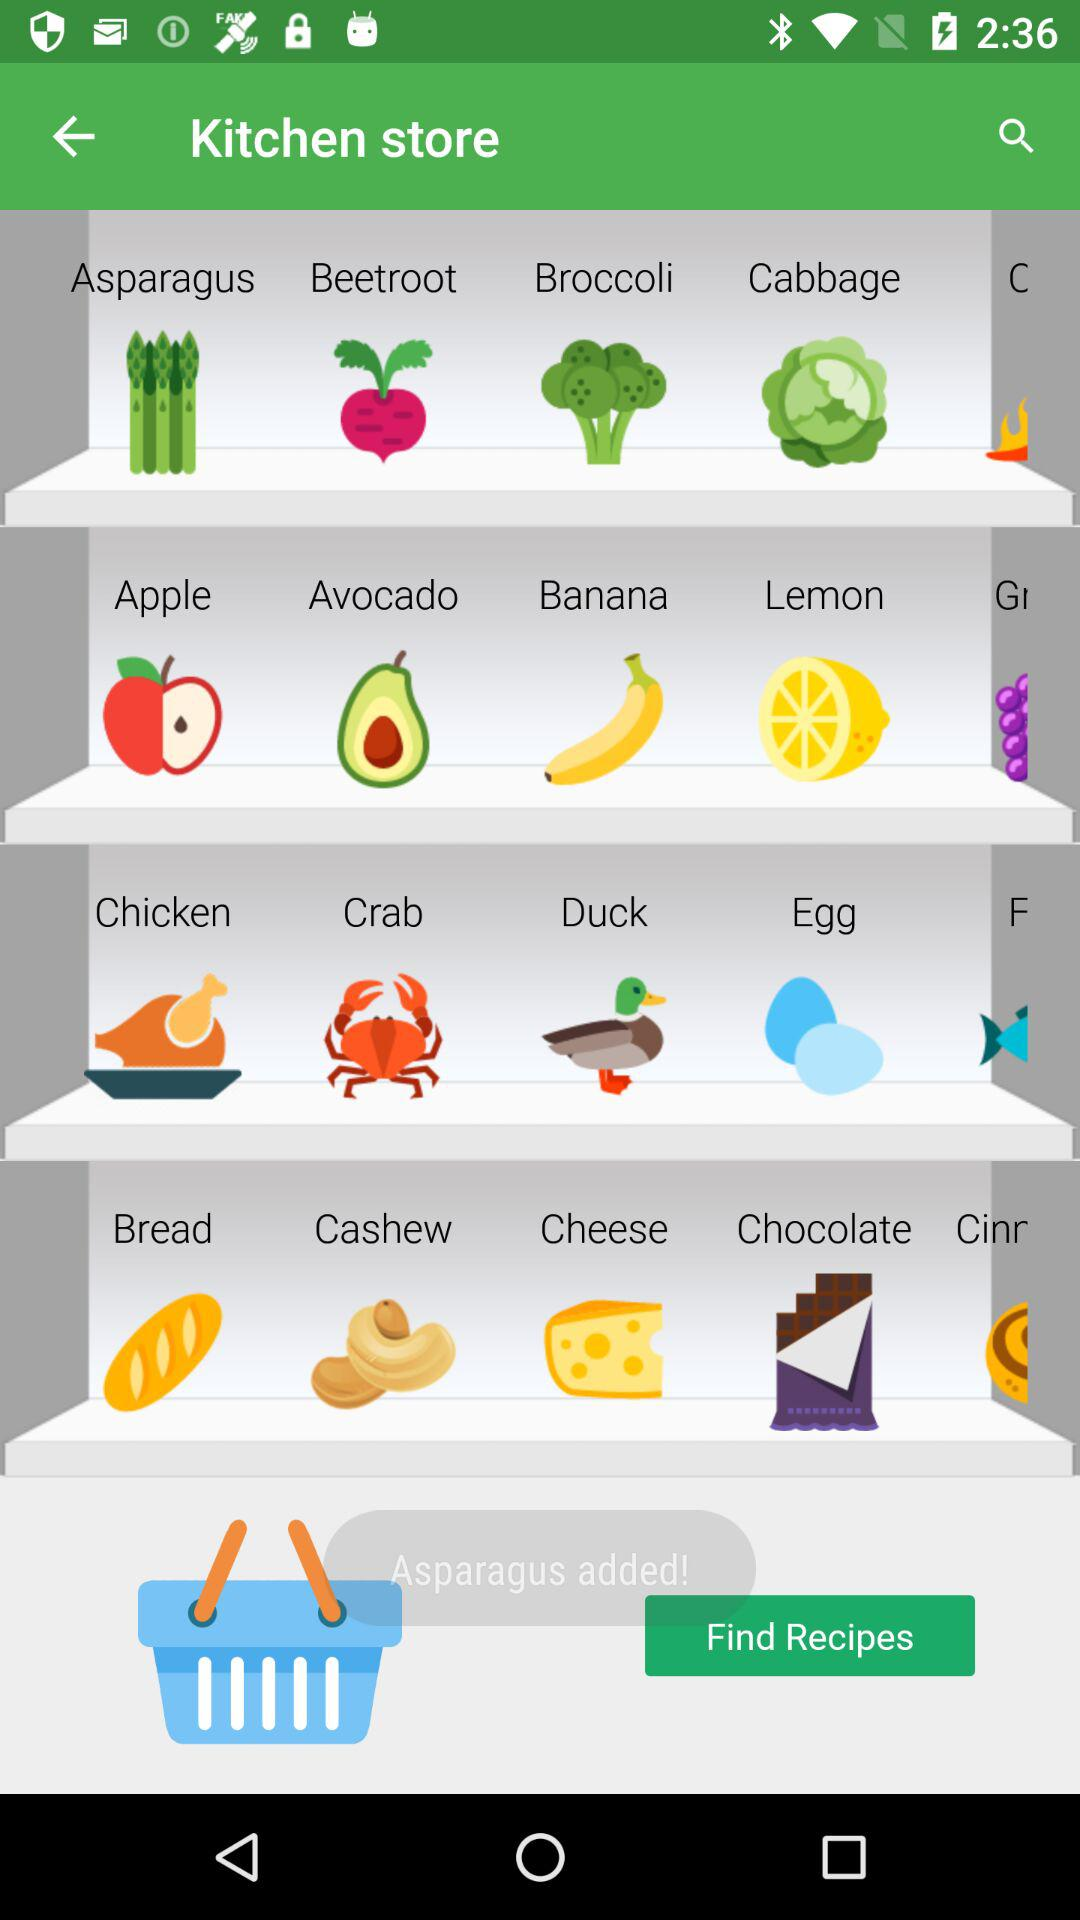How many items are in the shopping bag?
Answer the question using a single word or phrase. 1 